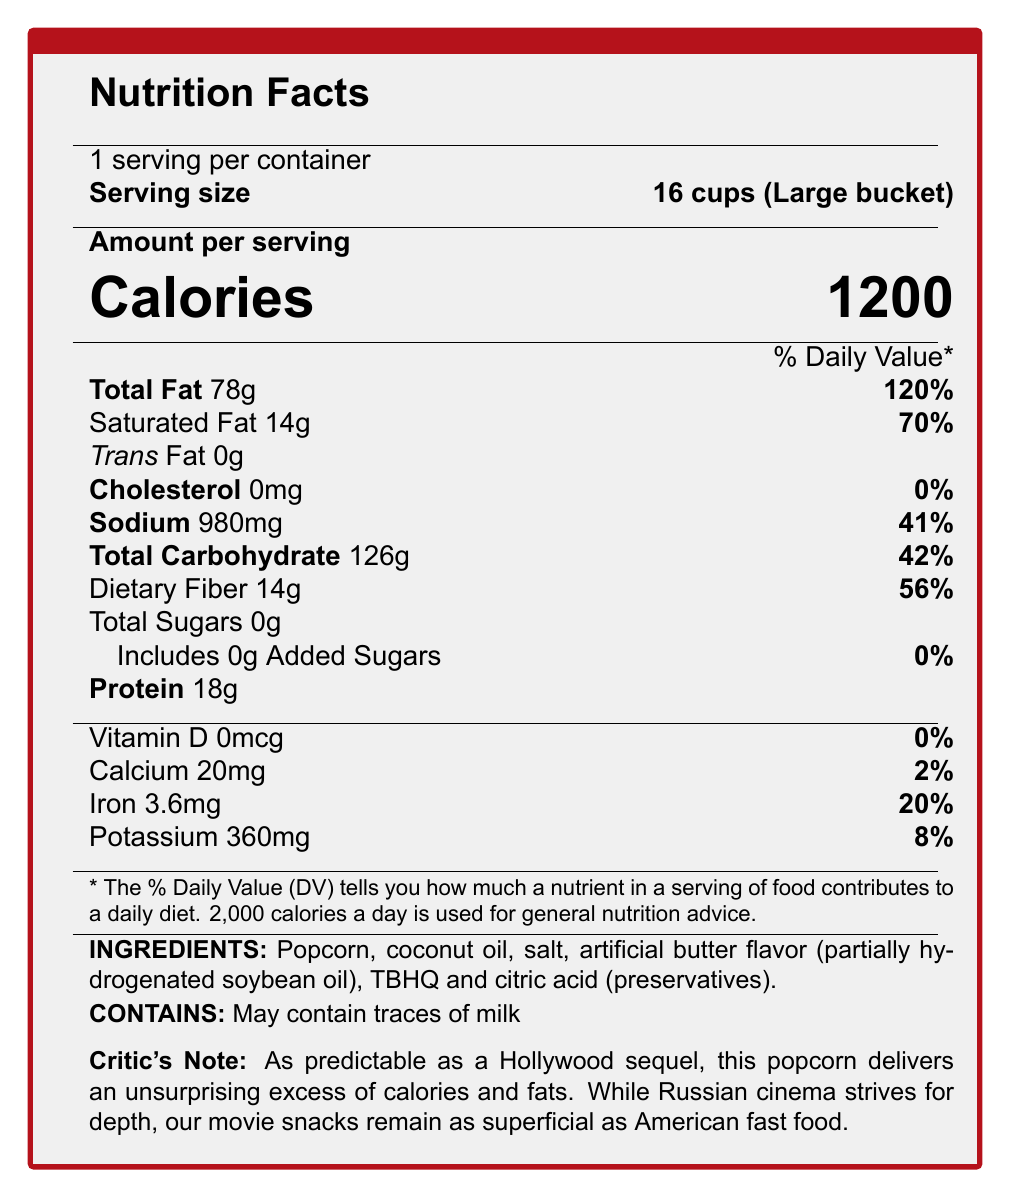what is the serving size? The serving size is specified as "Large bucket (16 cups)" in the document.
Answer: Large bucket (16 cups) how many calories are there in one serving of this popcorn? The document states that there are 1200 calories per serving.
Answer: 1200 what is the total fat content in a serving of this popcorn in grams? The total fat content is listed as 78 grams.
Answer: 78 grams how much saturated fat does one serving contain? The document mentions that the saturated fat content per serving is 14 grams.
Answer: 14 grams what ingredients in the popcorn might contribute to the hidden fats? The document lists "Coconut oil" and "Butter-flavored topping (partially hydrogenated soybean oil)" as sources of hidden fats.
Answer: Coconut oil, Butter-flavored topping (partially hydrogenated soybean oil) how many grams of dietary fiber are in one serving? The dietary fiber content is listed as 14 grams per serving.
Answer: 14 grams which of the following nutrients has the highest percent daily value in this popcorn? A. Sodium B. Total Carbohydrate C. Total Fat D. Iron The total fat has a percent daily value of 120%, which is the highest among the listed nutrients.
Answer: C. Total Fat which preservatives are used in this popcorn? A. TBHQ and Citric acid B. Ascorbic acid and BHA C. Sodium benzoate and BHT The document lists TBHQ and Citric acid as preservatives.
Answer: A. TBHQ and Citric acid does this popcorn contain any trans fat? The document states that the trans fat content is 0 grams.
Answer: No is there any added sugar in this popcorn? The document specifies that there are 0 grams of added sugars.
Answer: No summarize the main nutritional concerns associated with this popcorn. The popcorn contains 1200 calories, 78 grams of total fat (including 14 grams of saturated fat), and 980 milligrams of sodium per serving, which are all significantly high and pose nutritional concerns.
Answer: High in calories and unhealthy fats, with significant sodium and carbohydrate content. what is the average price of this popcorn in rubles? The additional information section lists the average price as 350 rubles.
Answer: 350 rubles which artificial flavors are used in the popcorn? The document mentions the use of artificial flavors but does not provide specific details on which artificial flavors are used.
Answer: Cannot be determined 